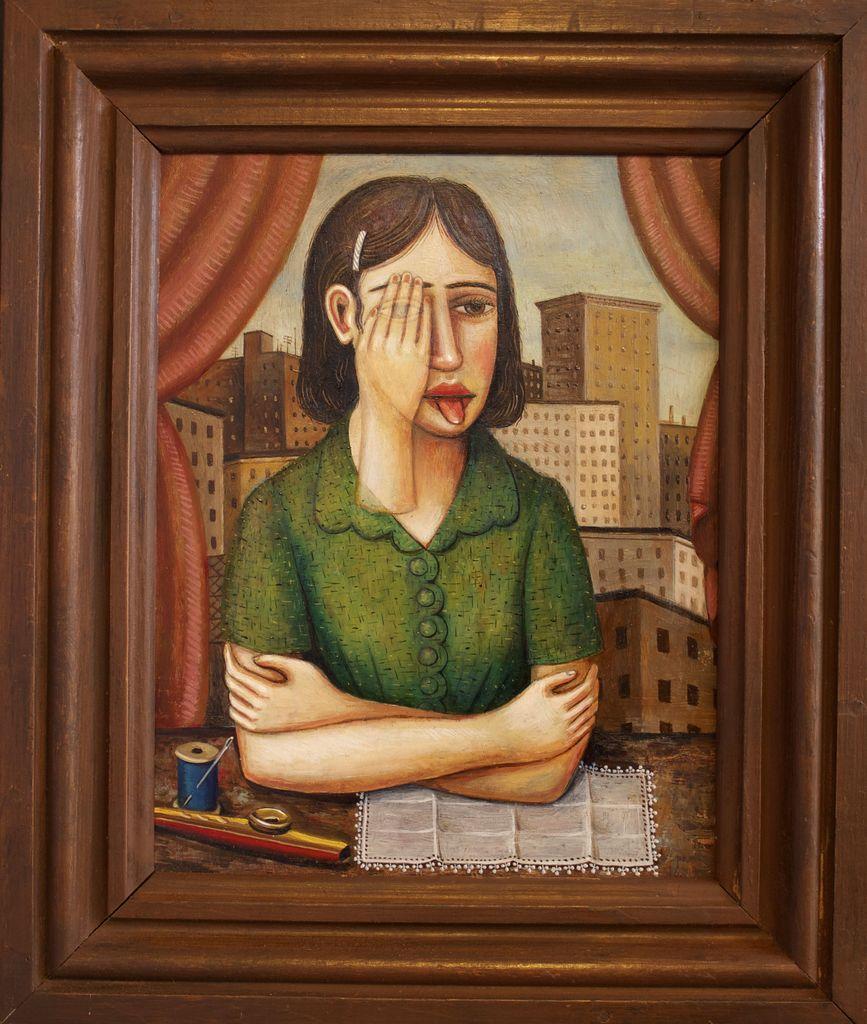Describe this image in one or two sentences. In this image we can see painting of a lady person who is wearing green color dress there is hand to her face there is cloth and needle-thread in front of her and in the background of the image there are some buildings. 